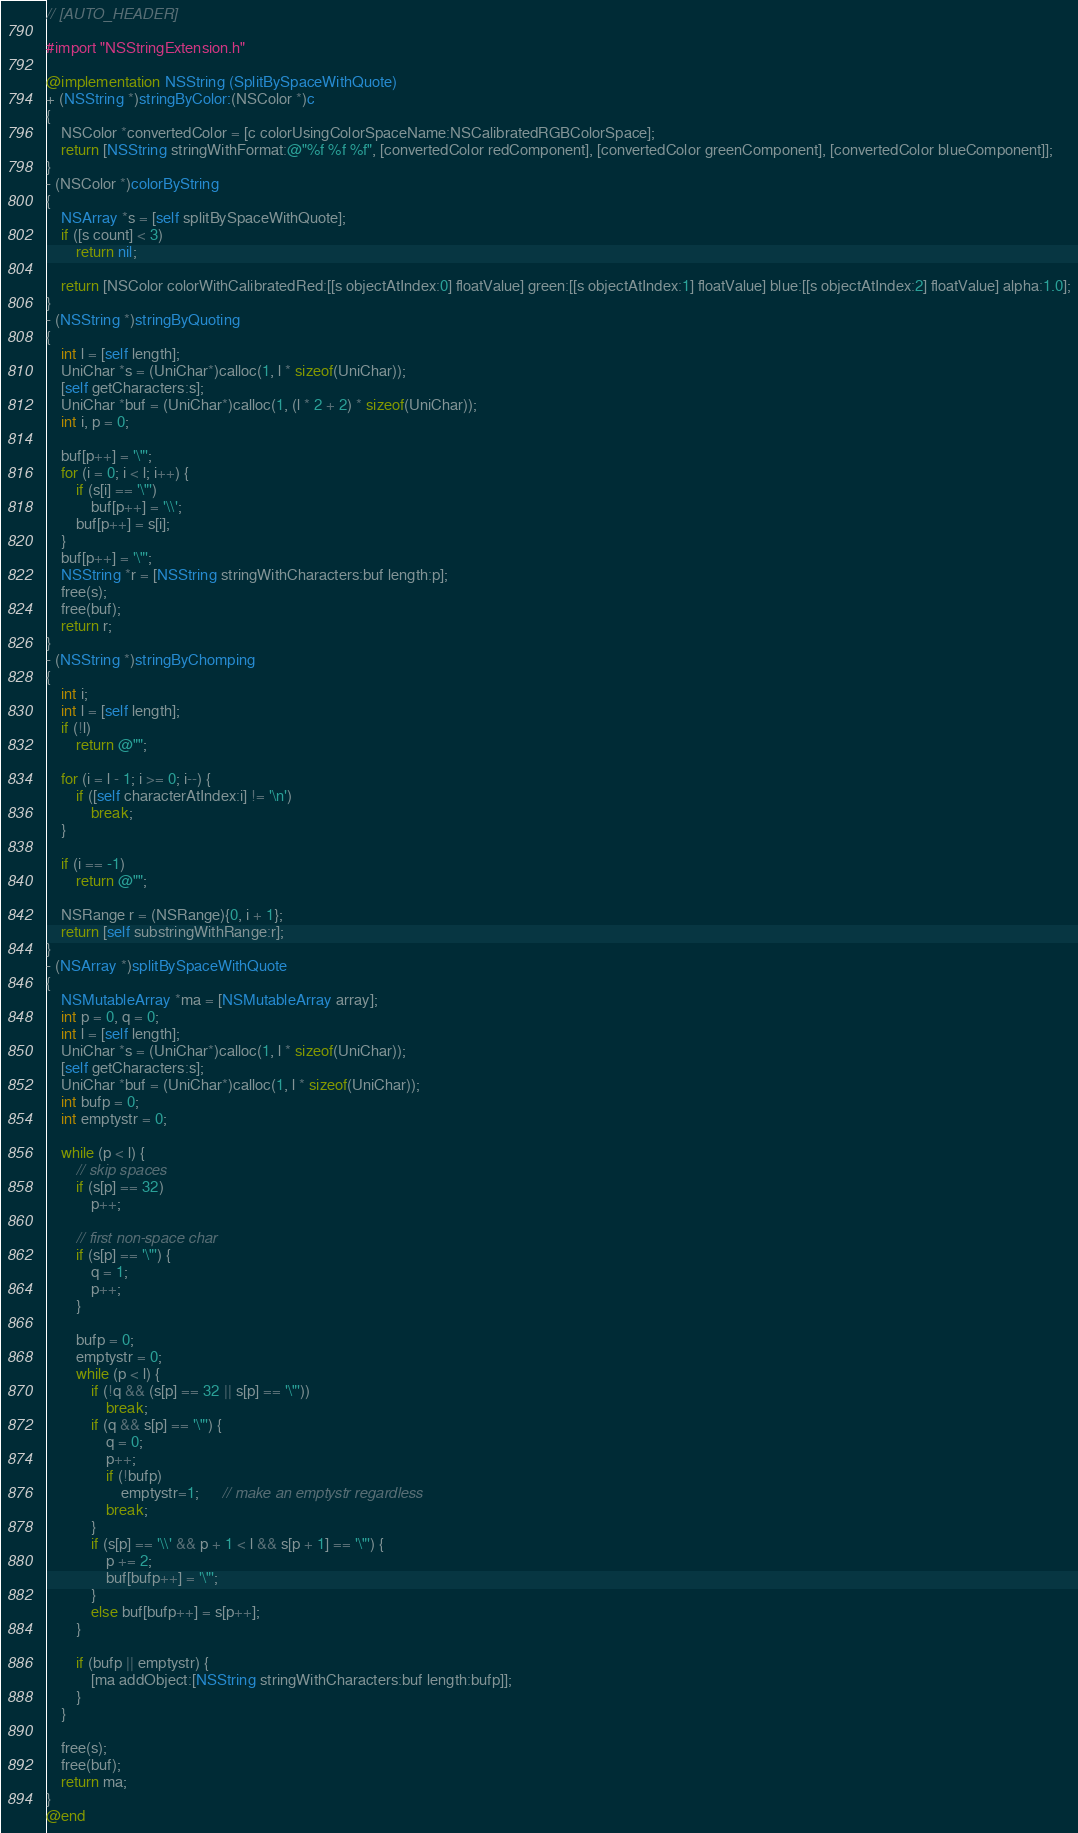<code> <loc_0><loc_0><loc_500><loc_500><_ObjectiveC_>// [AUTO_HEADER]

#import "NSStringExtension.h"

@implementation NSString (SplitBySpaceWithQuote)
+ (NSString *)stringByColor:(NSColor *)c
{	
	NSColor *convertedColor = [c colorUsingColorSpaceName:NSCalibratedRGBColorSpace];	
	return [NSString stringWithFormat:@"%f %f %f", [convertedColor redComponent], [convertedColor greenComponent], [convertedColor blueComponent]];
}
- (NSColor *)colorByString
{
	NSArray *s = [self splitBySpaceWithQuote];
	if ([s count] < 3)
		return nil;
	
	return [NSColor colorWithCalibratedRed:[[s objectAtIndex:0] floatValue] green:[[s objectAtIndex:1] floatValue] blue:[[s objectAtIndex:2] floatValue] alpha:1.0];
}
- (NSString *)stringByQuoting
{
    int l = [self length];
    UniChar *s = (UniChar*)calloc(1, l * sizeof(UniChar));
    [self getCharacters:s];
    UniChar *buf = (UniChar*)calloc(1, (l * 2 + 2) * sizeof(UniChar));
    int i, p = 0;
    
    buf[p++] = '\"';
    for (i = 0; i < l; i++) {
        if (s[i] == '\"')
			buf[p++] = '\\';
        buf[p++] = s[i];
    }
    buf[p++] = '\"';
    NSString *r = [NSString stringWithCharacters:buf length:p];
    free(s);
    free(buf);
    return r;
}
- (NSString *)stringByChomping
{
    int i;
    int l = [self length];
    if (!l)
		return @"";
    
    for (i = l - 1; i >= 0; i--) {
        if ([self characterAtIndex:i] != '\n')
			break;
    }
    
    if (i == -1)
		return @"";
	
    NSRange r = (NSRange){0, i + 1};
    return [self substringWithRange:r];
}
- (NSArray *)splitBySpaceWithQuote
{
    NSMutableArray *ma = [NSMutableArray array];
    int p = 0, q = 0;
    int l = [self length];
    UniChar *s = (UniChar*)calloc(1, l * sizeof(UniChar));
    [self getCharacters:s];
    UniChar *buf = (UniChar*)calloc(1, l * sizeof(UniChar));
    int bufp = 0;
    int emptystr = 0;
    
    while (p < l) {
        // skip spaces
        if (s[p] == 32)
			p++;
        
        // first non-space char
        if (s[p] == '\"') {
            q = 1;
            p++;
        }

        bufp = 0;
        emptystr = 0;
        while (p < l) {
            if (!q && (s[p] == 32 || s[p] == '\"'))
				break;
            if (q && s[p] == '\"') {
                q = 0;
                p++;
                if (!bufp) 
					emptystr=1;      // make an emptystr regardless
                break;
            }
            if (s[p] == '\\' && p + 1 < l && s[p + 1] == '\"') {
                p += 2;
                buf[bufp++] = '\"';
            }
            else buf[bufp++] = s[p++];
        }
        
        if (bufp || emptystr) {
            [ma addObject:[NSString stringWithCharacters:buf length:bufp]];
        }
    }
    
    free(s);
    free(buf);
    return ma;
}
@end

</code> 